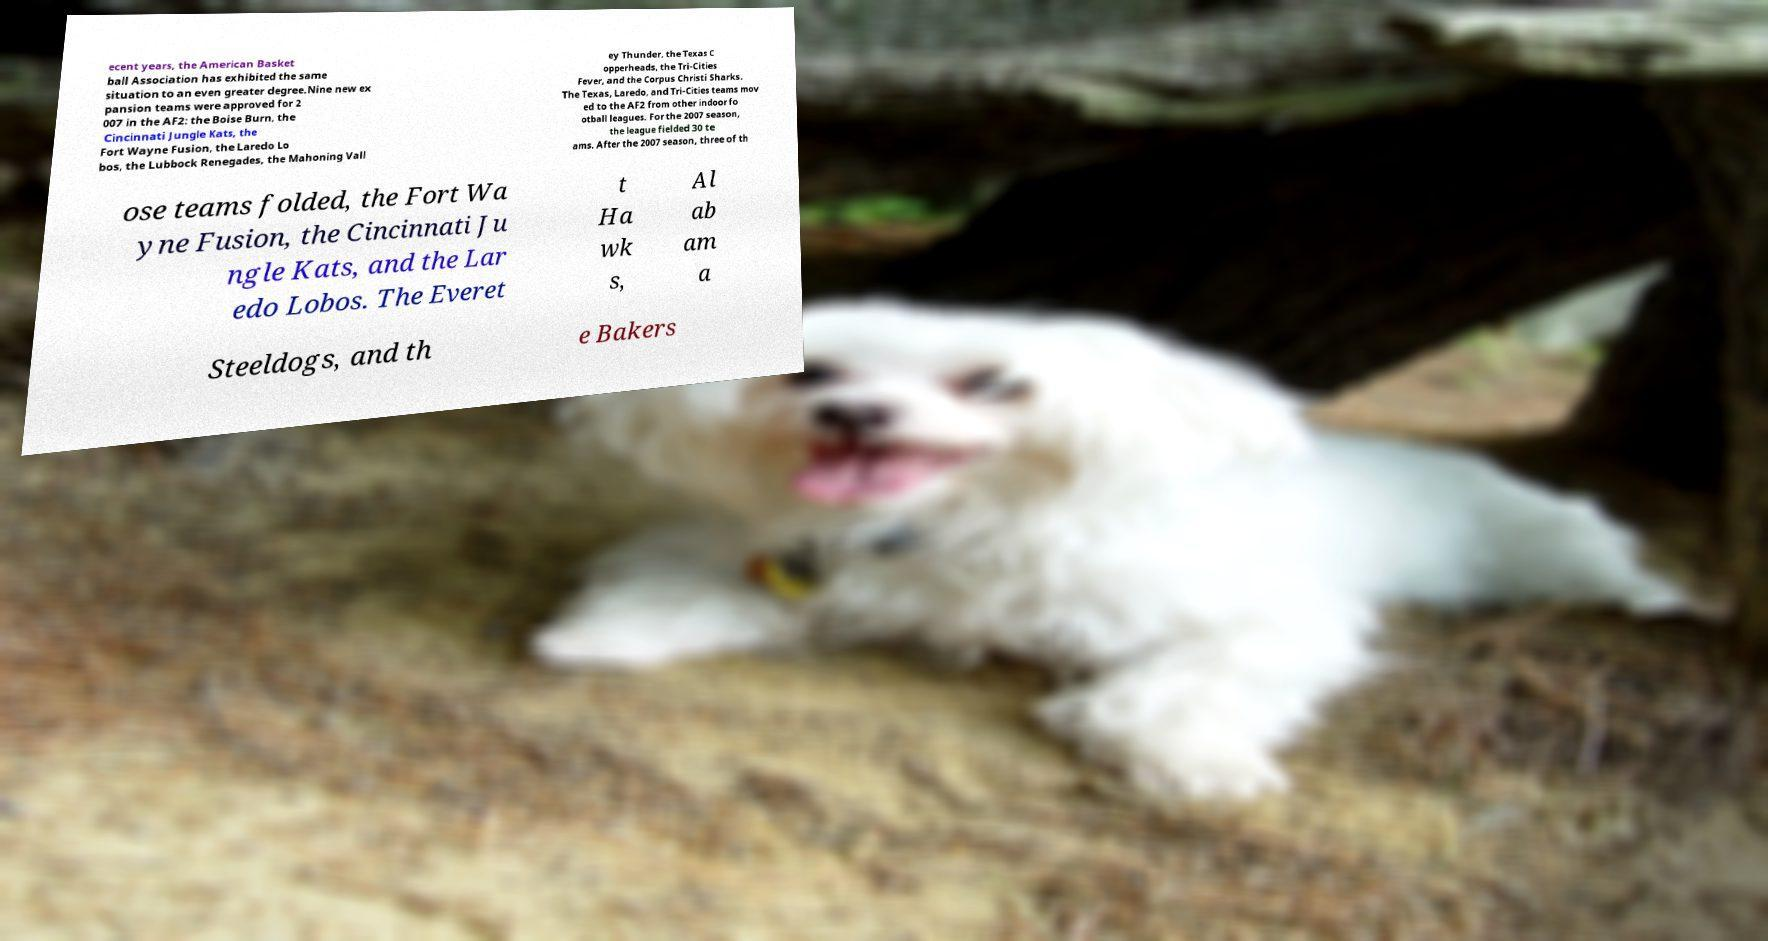Can you accurately transcribe the text from the provided image for me? ecent years, the American Basket ball Association has exhibited the same situation to an even greater degree.Nine new ex pansion teams were approved for 2 007 in the AF2: the Boise Burn, the Cincinnati Jungle Kats, the Fort Wayne Fusion, the Laredo Lo bos, the Lubbock Renegades, the Mahoning Vall ey Thunder, the Texas C opperheads, the Tri-Cities Fever, and the Corpus Christi Sharks. The Texas, Laredo, and Tri-Cities teams mov ed to the AF2 from other indoor fo otball leagues. For the 2007 season, the league fielded 30 te ams. After the 2007 season, three of th ose teams folded, the Fort Wa yne Fusion, the Cincinnati Ju ngle Kats, and the Lar edo Lobos. The Everet t Ha wk s, Al ab am a Steeldogs, and th e Bakers 